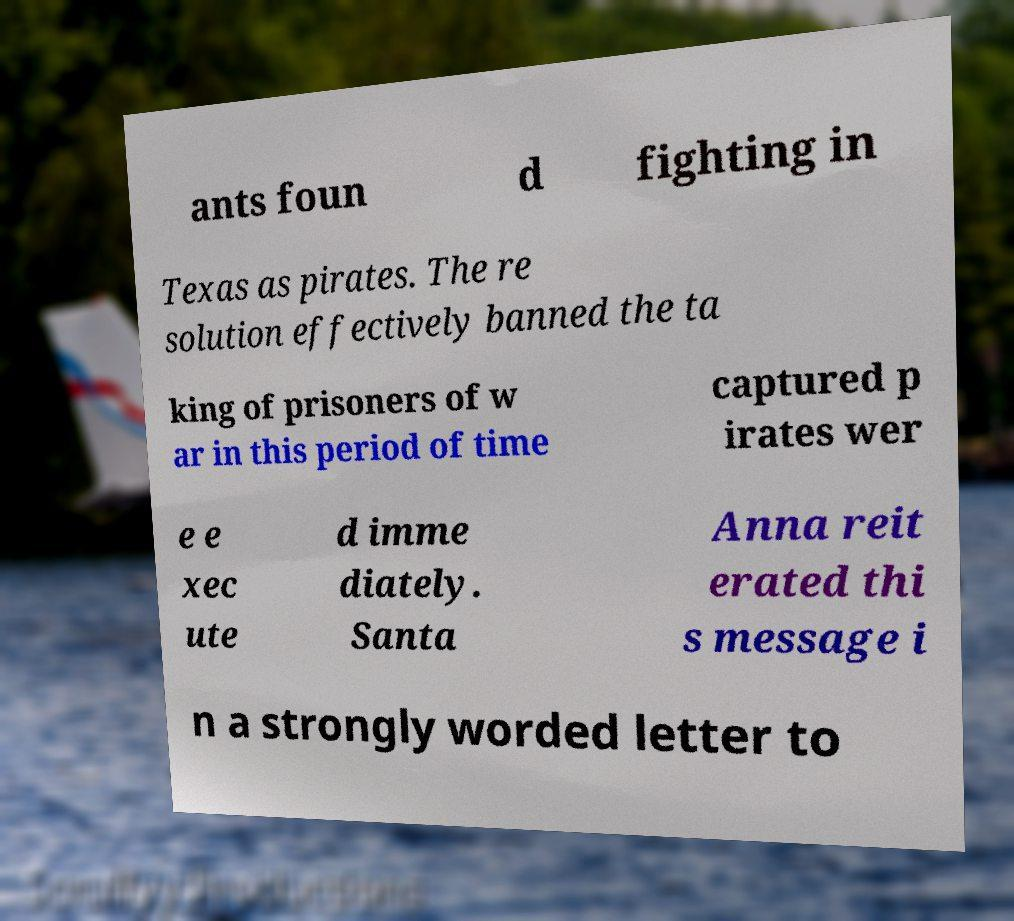Could you extract and type out the text from this image? ants foun d fighting in Texas as pirates. The re solution effectively banned the ta king of prisoners of w ar in this period of time captured p irates wer e e xec ute d imme diately. Santa Anna reit erated thi s message i n a strongly worded letter to 